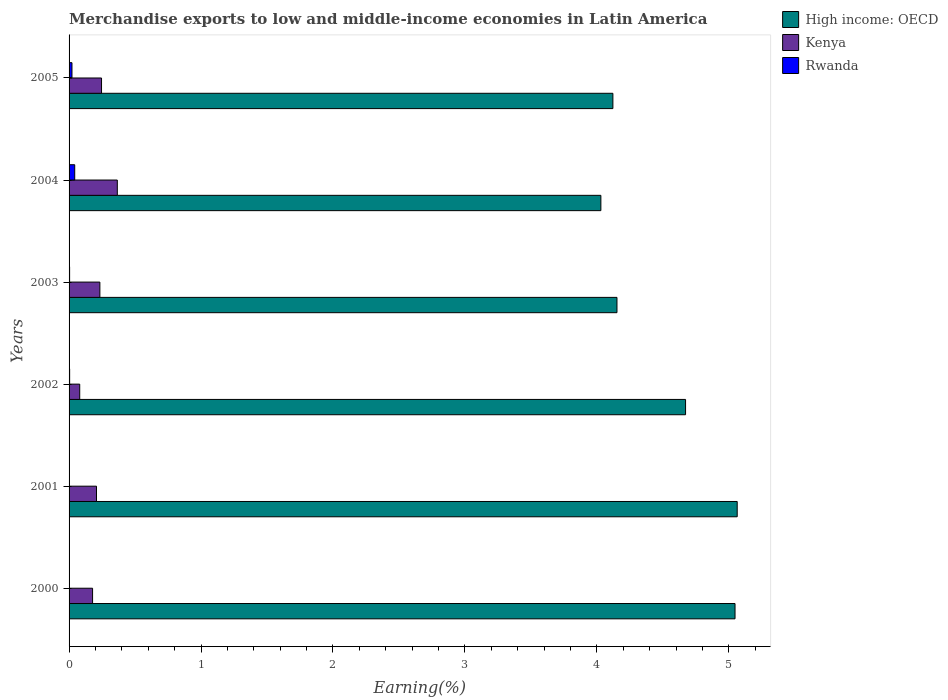How many different coloured bars are there?
Provide a succinct answer. 3. Are the number of bars on each tick of the Y-axis equal?
Ensure brevity in your answer.  Yes. How many bars are there on the 5th tick from the bottom?
Keep it short and to the point. 3. What is the percentage of amount earned from merchandise exports in High income: OECD in 2003?
Offer a very short reply. 4.15. Across all years, what is the maximum percentage of amount earned from merchandise exports in High income: OECD?
Give a very brief answer. 5.06. Across all years, what is the minimum percentage of amount earned from merchandise exports in Rwanda?
Ensure brevity in your answer.  0. In which year was the percentage of amount earned from merchandise exports in Rwanda maximum?
Your answer should be very brief. 2004. In which year was the percentage of amount earned from merchandise exports in High income: OECD minimum?
Your answer should be very brief. 2004. What is the total percentage of amount earned from merchandise exports in Kenya in the graph?
Give a very brief answer. 1.31. What is the difference between the percentage of amount earned from merchandise exports in Kenya in 2001 and that in 2005?
Provide a short and direct response. -0.04. What is the difference between the percentage of amount earned from merchandise exports in Rwanda in 2005 and the percentage of amount earned from merchandise exports in High income: OECD in 2003?
Your answer should be very brief. -4.13. What is the average percentage of amount earned from merchandise exports in Kenya per year?
Offer a terse response. 0.22. In the year 2002, what is the difference between the percentage of amount earned from merchandise exports in Kenya and percentage of amount earned from merchandise exports in High income: OECD?
Give a very brief answer. -4.59. What is the ratio of the percentage of amount earned from merchandise exports in High income: OECD in 2001 to that in 2003?
Offer a terse response. 1.22. Is the percentage of amount earned from merchandise exports in Rwanda in 2001 less than that in 2002?
Offer a terse response. Yes. Is the difference between the percentage of amount earned from merchandise exports in Kenya in 2003 and 2005 greater than the difference between the percentage of amount earned from merchandise exports in High income: OECD in 2003 and 2005?
Your answer should be compact. No. What is the difference between the highest and the second highest percentage of amount earned from merchandise exports in Kenya?
Keep it short and to the point. 0.12. What is the difference between the highest and the lowest percentage of amount earned from merchandise exports in High income: OECD?
Your answer should be compact. 1.03. What does the 1st bar from the top in 2003 represents?
Provide a succinct answer. Rwanda. What does the 3rd bar from the bottom in 2005 represents?
Ensure brevity in your answer.  Rwanda. Is it the case that in every year, the sum of the percentage of amount earned from merchandise exports in High income: OECD and percentage of amount earned from merchandise exports in Kenya is greater than the percentage of amount earned from merchandise exports in Rwanda?
Offer a very short reply. Yes. How many years are there in the graph?
Offer a terse response. 6. Are the values on the major ticks of X-axis written in scientific E-notation?
Make the answer very short. No. How many legend labels are there?
Provide a short and direct response. 3. How are the legend labels stacked?
Your response must be concise. Vertical. What is the title of the graph?
Your answer should be very brief. Merchandise exports to low and middle-income economies in Latin America. Does "Samoa" appear as one of the legend labels in the graph?
Your response must be concise. No. What is the label or title of the X-axis?
Offer a terse response. Earning(%). What is the Earning(%) of High income: OECD in 2000?
Keep it short and to the point. 5.05. What is the Earning(%) of Kenya in 2000?
Provide a succinct answer. 0.18. What is the Earning(%) of Rwanda in 2000?
Make the answer very short. 0. What is the Earning(%) of High income: OECD in 2001?
Your answer should be very brief. 5.06. What is the Earning(%) of Kenya in 2001?
Give a very brief answer. 0.21. What is the Earning(%) in Rwanda in 2001?
Offer a very short reply. 0. What is the Earning(%) in High income: OECD in 2002?
Your response must be concise. 4.67. What is the Earning(%) of Kenya in 2002?
Your response must be concise. 0.08. What is the Earning(%) of Rwanda in 2002?
Your answer should be very brief. 0. What is the Earning(%) of High income: OECD in 2003?
Ensure brevity in your answer.  4.15. What is the Earning(%) in Kenya in 2003?
Your response must be concise. 0.23. What is the Earning(%) in Rwanda in 2003?
Offer a terse response. 0. What is the Earning(%) in High income: OECD in 2004?
Your answer should be very brief. 4.03. What is the Earning(%) in Kenya in 2004?
Offer a very short reply. 0.37. What is the Earning(%) of Rwanda in 2004?
Your answer should be compact. 0.04. What is the Earning(%) of High income: OECD in 2005?
Ensure brevity in your answer.  4.12. What is the Earning(%) in Kenya in 2005?
Make the answer very short. 0.25. What is the Earning(%) of Rwanda in 2005?
Offer a terse response. 0.02. Across all years, what is the maximum Earning(%) in High income: OECD?
Keep it short and to the point. 5.06. Across all years, what is the maximum Earning(%) in Kenya?
Ensure brevity in your answer.  0.37. Across all years, what is the maximum Earning(%) in Rwanda?
Offer a very short reply. 0.04. Across all years, what is the minimum Earning(%) in High income: OECD?
Keep it short and to the point. 4.03. Across all years, what is the minimum Earning(%) of Kenya?
Your answer should be very brief. 0.08. Across all years, what is the minimum Earning(%) in Rwanda?
Your answer should be very brief. 0. What is the total Earning(%) of High income: OECD in the graph?
Your answer should be compact. 27.09. What is the total Earning(%) of Kenya in the graph?
Make the answer very short. 1.31. What is the total Earning(%) in Rwanda in the graph?
Offer a very short reply. 0.07. What is the difference between the Earning(%) of High income: OECD in 2000 and that in 2001?
Offer a very short reply. -0.02. What is the difference between the Earning(%) of Kenya in 2000 and that in 2001?
Provide a succinct answer. -0.03. What is the difference between the Earning(%) in Rwanda in 2000 and that in 2001?
Give a very brief answer. 0. What is the difference between the Earning(%) of High income: OECD in 2000 and that in 2002?
Keep it short and to the point. 0.37. What is the difference between the Earning(%) of Kenya in 2000 and that in 2002?
Provide a short and direct response. 0.1. What is the difference between the Earning(%) in Rwanda in 2000 and that in 2002?
Provide a succinct answer. -0. What is the difference between the Earning(%) of High income: OECD in 2000 and that in 2003?
Your answer should be very brief. 0.89. What is the difference between the Earning(%) in Kenya in 2000 and that in 2003?
Offer a terse response. -0.06. What is the difference between the Earning(%) in Rwanda in 2000 and that in 2003?
Make the answer very short. -0. What is the difference between the Earning(%) of High income: OECD in 2000 and that in 2004?
Provide a short and direct response. 1.02. What is the difference between the Earning(%) in Kenya in 2000 and that in 2004?
Your answer should be compact. -0.19. What is the difference between the Earning(%) of Rwanda in 2000 and that in 2004?
Your answer should be very brief. -0.04. What is the difference between the Earning(%) in High income: OECD in 2000 and that in 2005?
Your answer should be compact. 0.93. What is the difference between the Earning(%) in Kenya in 2000 and that in 2005?
Your answer should be very brief. -0.07. What is the difference between the Earning(%) in Rwanda in 2000 and that in 2005?
Make the answer very short. -0.02. What is the difference between the Earning(%) of High income: OECD in 2001 and that in 2002?
Offer a terse response. 0.39. What is the difference between the Earning(%) of Kenya in 2001 and that in 2002?
Keep it short and to the point. 0.13. What is the difference between the Earning(%) in Rwanda in 2001 and that in 2002?
Provide a short and direct response. -0. What is the difference between the Earning(%) of High income: OECD in 2001 and that in 2003?
Offer a terse response. 0.91. What is the difference between the Earning(%) in Kenya in 2001 and that in 2003?
Make the answer very short. -0.03. What is the difference between the Earning(%) in Rwanda in 2001 and that in 2003?
Keep it short and to the point. -0. What is the difference between the Earning(%) of High income: OECD in 2001 and that in 2004?
Provide a succinct answer. 1.03. What is the difference between the Earning(%) of Kenya in 2001 and that in 2004?
Give a very brief answer. -0.16. What is the difference between the Earning(%) of Rwanda in 2001 and that in 2004?
Your answer should be compact. -0.04. What is the difference between the Earning(%) in High income: OECD in 2001 and that in 2005?
Offer a terse response. 0.94. What is the difference between the Earning(%) in Kenya in 2001 and that in 2005?
Ensure brevity in your answer.  -0.04. What is the difference between the Earning(%) in Rwanda in 2001 and that in 2005?
Keep it short and to the point. -0.02. What is the difference between the Earning(%) in High income: OECD in 2002 and that in 2003?
Offer a very short reply. 0.52. What is the difference between the Earning(%) of Kenya in 2002 and that in 2003?
Offer a terse response. -0.15. What is the difference between the Earning(%) in High income: OECD in 2002 and that in 2004?
Your response must be concise. 0.64. What is the difference between the Earning(%) of Kenya in 2002 and that in 2004?
Your answer should be very brief. -0.28. What is the difference between the Earning(%) in Rwanda in 2002 and that in 2004?
Ensure brevity in your answer.  -0.04. What is the difference between the Earning(%) in High income: OECD in 2002 and that in 2005?
Give a very brief answer. 0.55. What is the difference between the Earning(%) of Kenya in 2002 and that in 2005?
Your answer should be very brief. -0.17. What is the difference between the Earning(%) of Rwanda in 2002 and that in 2005?
Provide a short and direct response. -0.02. What is the difference between the Earning(%) of High income: OECD in 2003 and that in 2004?
Your answer should be very brief. 0.12. What is the difference between the Earning(%) in Kenya in 2003 and that in 2004?
Keep it short and to the point. -0.13. What is the difference between the Earning(%) of Rwanda in 2003 and that in 2004?
Your answer should be compact. -0.04. What is the difference between the Earning(%) of High income: OECD in 2003 and that in 2005?
Your answer should be very brief. 0.03. What is the difference between the Earning(%) in Kenya in 2003 and that in 2005?
Make the answer very short. -0.01. What is the difference between the Earning(%) in Rwanda in 2003 and that in 2005?
Make the answer very short. -0.02. What is the difference between the Earning(%) in High income: OECD in 2004 and that in 2005?
Your answer should be very brief. -0.09. What is the difference between the Earning(%) of Kenya in 2004 and that in 2005?
Your answer should be compact. 0.12. What is the difference between the Earning(%) in Rwanda in 2004 and that in 2005?
Keep it short and to the point. 0.02. What is the difference between the Earning(%) of High income: OECD in 2000 and the Earning(%) of Kenya in 2001?
Your answer should be very brief. 4.84. What is the difference between the Earning(%) in High income: OECD in 2000 and the Earning(%) in Rwanda in 2001?
Ensure brevity in your answer.  5.05. What is the difference between the Earning(%) of Kenya in 2000 and the Earning(%) of Rwanda in 2001?
Your response must be concise. 0.18. What is the difference between the Earning(%) of High income: OECD in 2000 and the Earning(%) of Kenya in 2002?
Offer a very short reply. 4.97. What is the difference between the Earning(%) in High income: OECD in 2000 and the Earning(%) in Rwanda in 2002?
Your answer should be compact. 5.04. What is the difference between the Earning(%) of Kenya in 2000 and the Earning(%) of Rwanda in 2002?
Offer a terse response. 0.17. What is the difference between the Earning(%) in High income: OECD in 2000 and the Earning(%) in Kenya in 2003?
Your answer should be compact. 4.81. What is the difference between the Earning(%) of High income: OECD in 2000 and the Earning(%) of Rwanda in 2003?
Provide a short and direct response. 5.04. What is the difference between the Earning(%) in Kenya in 2000 and the Earning(%) in Rwanda in 2003?
Ensure brevity in your answer.  0.17. What is the difference between the Earning(%) of High income: OECD in 2000 and the Earning(%) of Kenya in 2004?
Your response must be concise. 4.68. What is the difference between the Earning(%) of High income: OECD in 2000 and the Earning(%) of Rwanda in 2004?
Keep it short and to the point. 5. What is the difference between the Earning(%) of Kenya in 2000 and the Earning(%) of Rwanda in 2004?
Keep it short and to the point. 0.14. What is the difference between the Earning(%) in High income: OECD in 2000 and the Earning(%) in Kenya in 2005?
Provide a short and direct response. 4.8. What is the difference between the Earning(%) in High income: OECD in 2000 and the Earning(%) in Rwanda in 2005?
Ensure brevity in your answer.  5.03. What is the difference between the Earning(%) of Kenya in 2000 and the Earning(%) of Rwanda in 2005?
Provide a succinct answer. 0.16. What is the difference between the Earning(%) of High income: OECD in 2001 and the Earning(%) of Kenya in 2002?
Your answer should be compact. 4.98. What is the difference between the Earning(%) in High income: OECD in 2001 and the Earning(%) in Rwanda in 2002?
Offer a terse response. 5.06. What is the difference between the Earning(%) of Kenya in 2001 and the Earning(%) of Rwanda in 2002?
Make the answer very short. 0.2. What is the difference between the Earning(%) in High income: OECD in 2001 and the Earning(%) in Kenya in 2003?
Give a very brief answer. 4.83. What is the difference between the Earning(%) in High income: OECD in 2001 and the Earning(%) in Rwanda in 2003?
Make the answer very short. 5.06. What is the difference between the Earning(%) of Kenya in 2001 and the Earning(%) of Rwanda in 2003?
Give a very brief answer. 0.2. What is the difference between the Earning(%) of High income: OECD in 2001 and the Earning(%) of Kenya in 2004?
Your response must be concise. 4.7. What is the difference between the Earning(%) of High income: OECD in 2001 and the Earning(%) of Rwanda in 2004?
Offer a terse response. 5.02. What is the difference between the Earning(%) of Kenya in 2001 and the Earning(%) of Rwanda in 2004?
Your answer should be compact. 0.17. What is the difference between the Earning(%) of High income: OECD in 2001 and the Earning(%) of Kenya in 2005?
Provide a succinct answer. 4.82. What is the difference between the Earning(%) in High income: OECD in 2001 and the Earning(%) in Rwanda in 2005?
Offer a very short reply. 5.04. What is the difference between the Earning(%) in Kenya in 2001 and the Earning(%) in Rwanda in 2005?
Provide a succinct answer. 0.19. What is the difference between the Earning(%) in High income: OECD in 2002 and the Earning(%) in Kenya in 2003?
Offer a terse response. 4.44. What is the difference between the Earning(%) of High income: OECD in 2002 and the Earning(%) of Rwanda in 2003?
Your response must be concise. 4.67. What is the difference between the Earning(%) in Kenya in 2002 and the Earning(%) in Rwanda in 2003?
Provide a succinct answer. 0.08. What is the difference between the Earning(%) of High income: OECD in 2002 and the Earning(%) of Kenya in 2004?
Offer a very short reply. 4.31. What is the difference between the Earning(%) of High income: OECD in 2002 and the Earning(%) of Rwanda in 2004?
Offer a very short reply. 4.63. What is the difference between the Earning(%) in Kenya in 2002 and the Earning(%) in Rwanda in 2004?
Provide a succinct answer. 0.04. What is the difference between the Earning(%) of High income: OECD in 2002 and the Earning(%) of Kenya in 2005?
Keep it short and to the point. 4.43. What is the difference between the Earning(%) in High income: OECD in 2002 and the Earning(%) in Rwanda in 2005?
Ensure brevity in your answer.  4.65. What is the difference between the Earning(%) of Kenya in 2002 and the Earning(%) of Rwanda in 2005?
Make the answer very short. 0.06. What is the difference between the Earning(%) of High income: OECD in 2003 and the Earning(%) of Kenya in 2004?
Make the answer very short. 3.79. What is the difference between the Earning(%) of High income: OECD in 2003 and the Earning(%) of Rwanda in 2004?
Offer a very short reply. 4.11. What is the difference between the Earning(%) of Kenya in 2003 and the Earning(%) of Rwanda in 2004?
Provide a succinct answer. 0.19. What is the difference between the Earning(%) of High income: OECD in 2003 and the Earning(%) of Kenya in 2005?
Your answer should be very brief. 3.91. What is the difference between the Earning(%) in High income: OECD in 2003 and the Earning(%) in Rwanda in 2005?
Give a very brief answer. 4.13. What is the difference between the Earning(%) in Kenya in 2003 and the Earning(%) in Rwanda in 2005?
Offer a very short reply. 0.21. What is the difference between the Earning(%) in High income: OECD in 2004 and the Earning(%) in Kenya in 2005?
Provide a short and direct response. 3.78. What is the difference between the Earning(%) of High income: OECD in 2004 and the Earning(%) of Rwanda in 2005?
Your answer should be compact. 4.01. What is the difference between the Earning(%) in Kenya in 2004 and the Earning(%) in Rwanda in 2005?
Your response must be concise. 0.34. What is the average Earning(%) of High income: OECD per year?
Your answer should be compact. 4.51. What is the average Earning(%) in Kenya per year?
Your answer should be very brief. 0.22. What is the average Earning(%) in Rwanda per year?
Ensure brevity in your answer.  0.01. In the year 2000, what is the difference between the Earning(%) of High income: OECD and Earning(%) of Kenya?
Give a very brief answer. 4.87. In the year 2000, what is the difference between the Earning(%) of High income: OECD and Earning(%) of Rwanda?
Offer a very short reply. 5.05. In the year 2000, what is the difference between the Earning(%) in Kenya and Earning(%) in Rwanda?
Offer a terse response. 0.18. In the year 2001, what is the difference between the Earning(%) in High income: OECD and Earning(%) in Kenya?
Offer a very short reply. 4.86. In the year 2001, what is the difference between the Earning(%) in High income: OECD and Earning(%) in Rwanda?
Your answer should be very brief. 5.06. In the year 2001, what is the difference between the Earning(%) of Kenya and Earning(%) of Rwanda?
Your response must be concise. 0.21. In the year 2002, what is the difference between the Earning(%) of High income: OECD and Earning(%) of Kenya?
Your response must be concise. 4.59. In the year 2002, what is the difference between the Earning(%) in High income: OECD and Earning(%) in Rwanda?
Make the answer very short. 4.67. In the year 2002, what is the difference between the Earning(%) of Kenya and Earning(%) of Rwanda?
Your answer should be compact. 0.08. In the year 2003, what is the difference between the Earning(%) in High income: OECD and Earning(%) in Kenya?
Give a very brief answer. 3.92. In the year 2003, what is the difference between the Earning(%) of High income: OECD and Earning(%) of Rwanda?
Provide a succinct answer. 4.15. In the year 2003, what is the difference between the Earning(%) in Kenya and Earning(%) in Rwanda?
Offer a very short reply. 0.23. In the year 2004, what is the difference between the Earning(%) in High income: OECD and Earning(%) in Kenya?
Offer a terse response. 3.66. In the year 2004, what is the difference between the Earning(%) of High income: OECD and Earning(%) of Rwanda?
Offer a terse response. 3.99. In the year 2004, what is the difference between the Earning(%) in Kenya and Earning(%) in Rwanda?
Your answer should be compact. 0.32. In the year 2005, what is the difference between the Earning(%) of High income: OECD and Earning(%) of Kenya?
Give a very brief answer. 3.88. In the year 2005, what is the difference between the Earning(%) of High income: OECD and Earning(%) of Rwanda?
Offer a very short reply. 4.1. In the year 2005, what is the difference between the Earning(%) of Kenya and Earning(%) of Rwanda?
Give a very brief answer. 0.22. What is the ratio of the Earning(%) in Kenya in 2000 to that in 2001?
Your response must be concise. 0.86. What is the ratio of the Earning(%) of Rwanda in 2000 to that in 2001?
Your answer should be compact. 4.4. What is the ratio of the Earning(%) in High income: OECD in 2000 to that in 2002?
Provide a succinct answer. 1.08. What is the ratio of the Earning(%) in Kenya in 2000 to that in 2002?
Your answer should be compact. 2.21. What is the ratio of the Earning(%) in Rwanda in 2000 to that in 2002?
Your answer should be compact. 0.35. What is the ratio of the Earning(%) in High income: OECD in 2000 to that in 2003?
Offer a terse response. 1.22. What is the ratio of the Earning(%) of Kenya in 2000 to that in 2003?
Your response must be concise. 0.76. What is the ratio of the Earning(%) in Rwanda in 2000 to that in 2003?
Provide a short and direct response. 0.36. What is the ratio of the Earning(%) of High income: OECD in 2000 to that in 2004?
Give a very brief answer. 1.25. What is the ratio of the Earning(%) in Kenya in 2000 to that in 2004?
Give a very brief answer. 0.49. What is the ratio of the Earning(%) of Rwanda in 2000 to that in 2004?
Ensure brevity in your answer.  0.03. What is the ratio of the Earning(%) of High income: OECD in 2000 to that in 2005?
Provide a succinct answer. 1.22. What is the ratio of the Earning(%) in Kenya in 2000 to that in 2005?
Ensure brevity in your answer.  0.72. What is the ratio of the Earning(%) in Rwanda in 2000 to that in 2005?
Your response must be concise. 0.07. What is the ratio of the Earning(%) in High income: OECD in 2001 to that in 2002?
Your answer should be compact. 1.08. What is the ratio of the Earning(%) of Kenya in 2001 to that in 2002?
Your response must be concise. 2.58. What is the ratio of the Earning(%) of Rwanda in 2001 to that in 2002?
Provide a succinct answer. 0.08. What is the ratio of the Earning(%) of High income: OECD in 2001 to that in 2003?
Your answer should be compact. 1.22. What is the ratio of the Earning(%) of Kenya in 2001 to that in 2003?
Your answer should be compact. 0.89. What is the ratio of the Earning(%) in Rwanda in 2001 to that in 2003?
Provide a succinct answer. 0.08. What is the ratio of the Earning(%) of High income: OECD in 2001 to that in 2004?
Make the answer very short. 1.26. What is the ratio of the Earning(%) of Kenya in 2001 to that in 2004?
Provide a short and direct response. 0.57. What is the ratio of the Earning(%) in Rwanda in 2001 to that in 2004?
Offer a very short reply. 0.01. What is the ratio of the Earning(%) of High income: OECD in 2001 to that in 2005?
Ensure brevity in your answer.  1.23. What is the ratio of the Earning(%) of Kenya in 2001 to that in 2005?
Provide a succinct answer. 0.85. What is the ratio of the Earning(%) of Rwanda in 2001 to that in 2005?
Provide a short and direct response. 0.02. What is the ratio of the Earning(%) of High income: OECD in 2002 to that in 2003?
Offer a very short reply. 1.13. What is the ratio of the Earning(%) of Kenya in 2002 to that in 2003?
Give a very brief answer. 0.35. What is the ratio of the Earning(%) of Rwanda in 2002 to that in 2003?
Make the answer very short. 1.05. What is the ratio of the Earning(%) of High income: OECD in 2002 to that in 2004?
Keep it short and to the point. 1.16. What is the ratio of the Earning(%) of Kenya in 2002 to that in 2004?
Ensure brevity in your answer.  0.22. What is the ratio of the Earning(%) in Rwanda in 2002 to that in 2004?
Give a very brief answer. 0.1. What is the ratio of the Earning(%) in High income: OECD in 2002 to that in 2005?
Ensure brevity in your answer.  1.13. What is the ratio of the Earning(%) of Kenya in 2002 to that in 2005?
Make the answer very short. 0.33. What is the ratio of the Earning(%) of Rwanda in 2002 to that in 2005?
Keep it short and to the point. 0.2. What is the ratio of the Earning(%) of High income: OECD in 2003 to that in 2004?
Provide a succinct answer. 1.03. What is the ratio of the Earning(%) of Kenya in 2003 to that in 2004?
Provide a short and direct response. 0.64. What is the ratio of the Earning(%) of Rwanda in 2003 to that in 2004?
Your answer should be compact. 0.1. What is the ratio of the Earning(%) in High income: OECD in 2003 to that in 2005?
Offer a very short reply. 1.01. What is the ratio of the Earning(%) in Kenya in 2003 to that in 2005?
Offer a terse response. 0.95. What is the ratio of the Earning(%) in Rwanda in 2003 to that in 2005?
Offer a terse response. 0.19. What is the ratio of the Earning(%) in High income: OECD in 2004 to that in 2005?
Your answer should be very brief. 0.98. What is the ratio of the Earning(%) of Kenya in 2004 to that in 2005?
Make the answer very short. 1.49. What is the ratio of the Earning(%) in Rwanda in 2004 to that in 2005?
Give a very brief answer. 1.96. What is the difference between the highest and the second highest Earning(%) of High income: OECD?
Provide a short and direct response. 0.02. What is the difference between the highest and the second highest Earning(%) of Kenya?
Provide a succinct answer. 0.12. What is the difference between the highest and the second highest Earning(%) in Rwanda?
Ensure brevity in your answer.  0.02. What is the difference between the highest and the lowest Earning(%) of High income: OECD?
Ensure brevity in your answer.  1.03. What is the difference between the highest and the lowest Earning(%) of Kenya?
Give a very brief answer. 0.28. What is the difference between the highest and the lowest Earning(%) of Rwanda?
Make the answer very short. 0.04. 